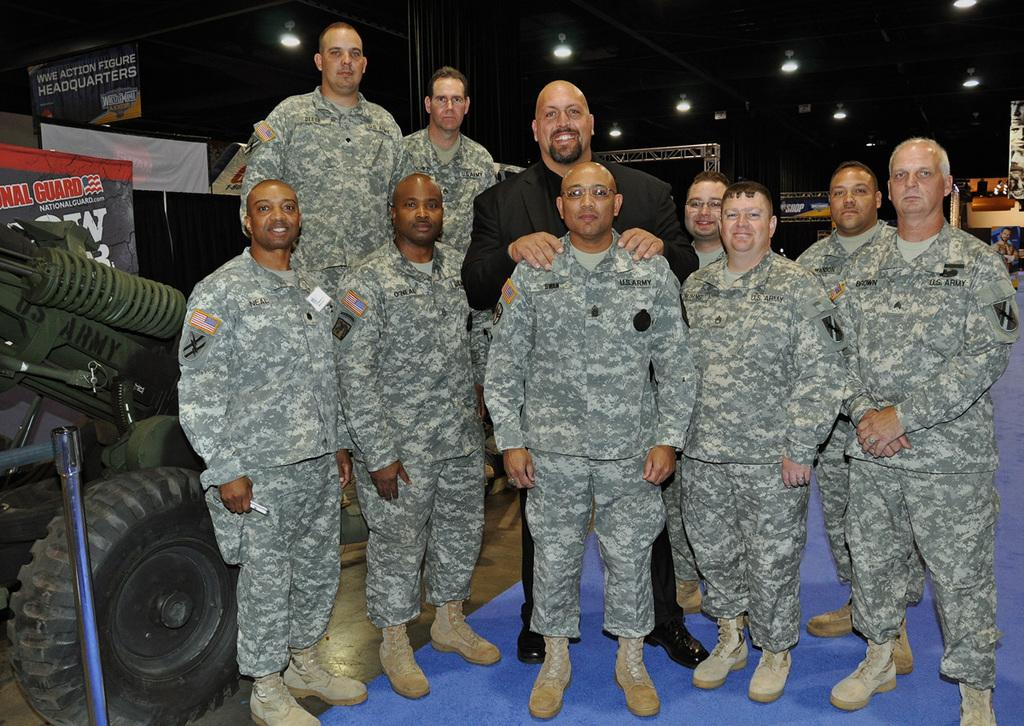What are the people in the image doing? The persons in the image are standing on the ground. What can be seen in the background of the image? There are lightnings in the background. What is located on the left side of the image? There are vehicles on the left side of the image. How many arms does the person in the image have? The image does not show any person with an abnormal number of arms; the persons in the image have the standard two arms. What type of trip are the persons in the image taking? The image does not provide any information about a trip or journey; it only shows persons standing on the ground and vehicles on the left side. 